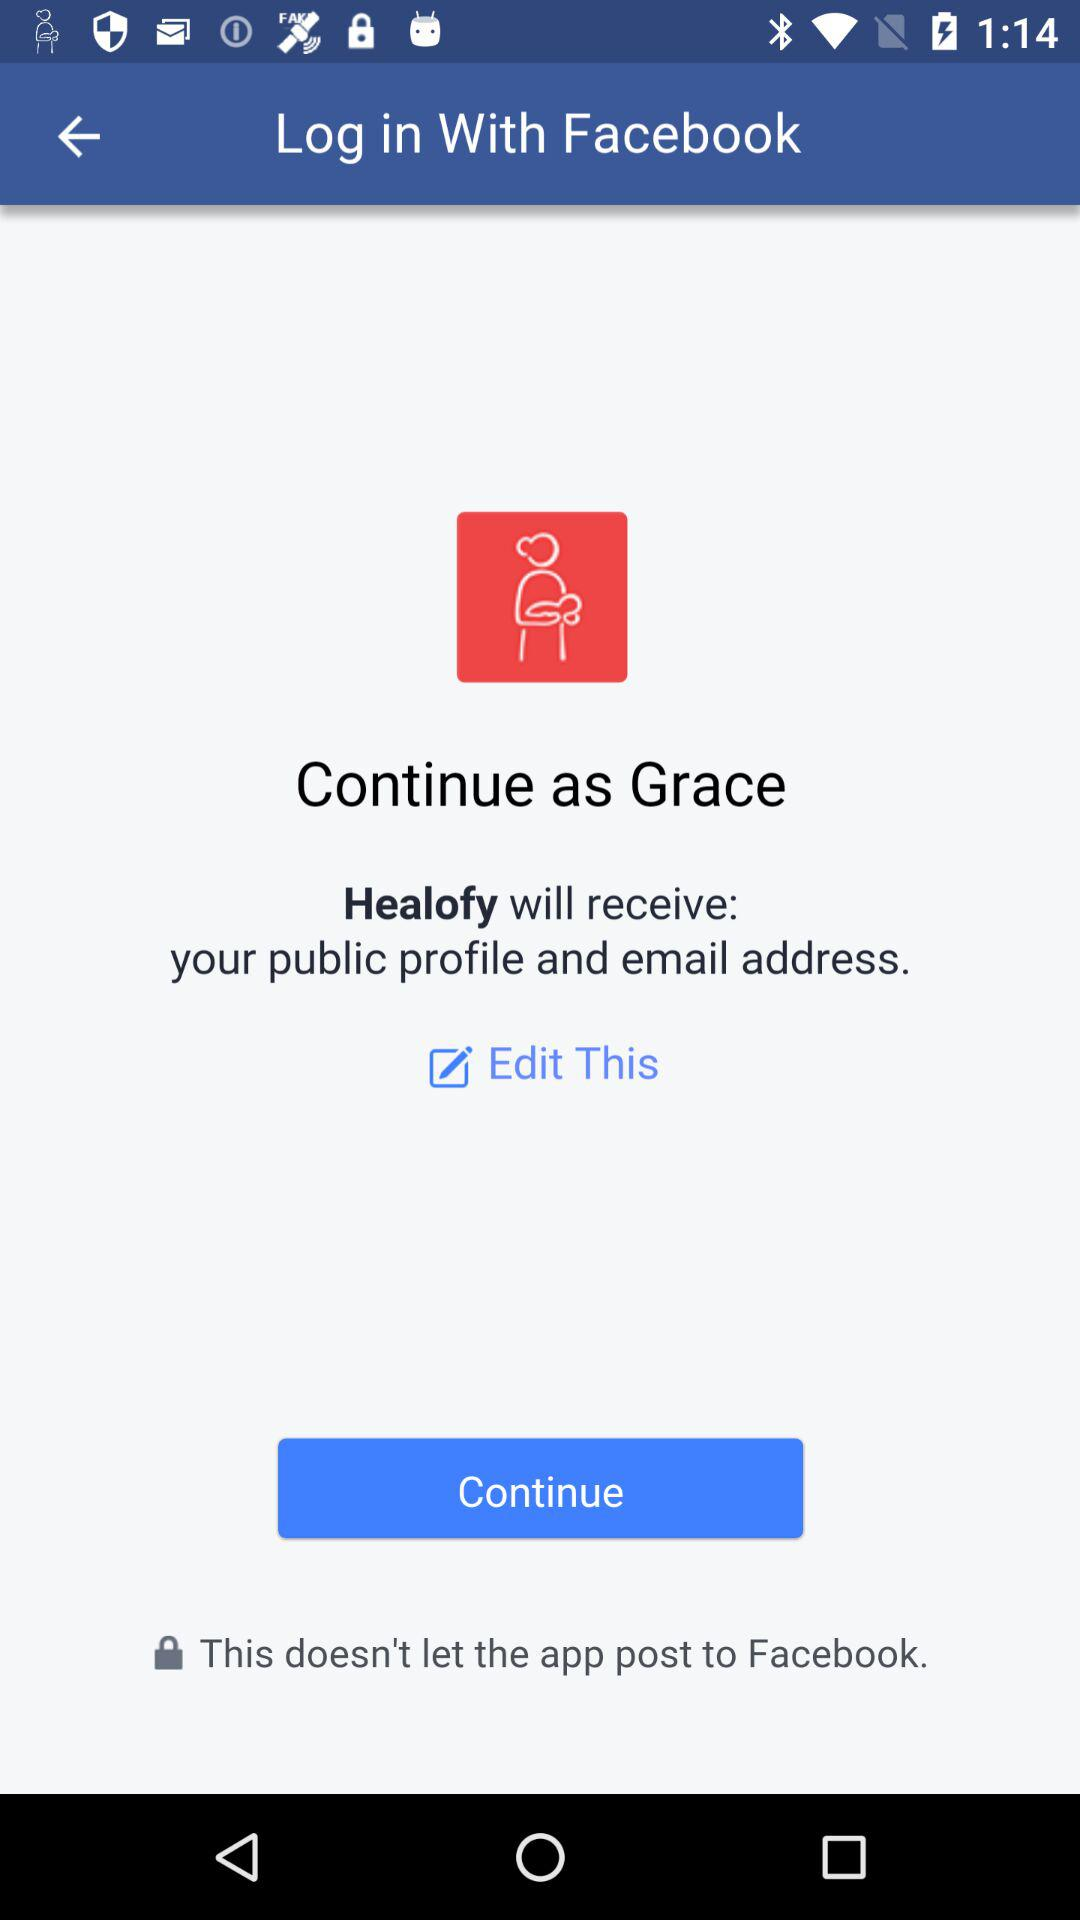What application is asking for permission? The application asking for permission is "Healofy". 